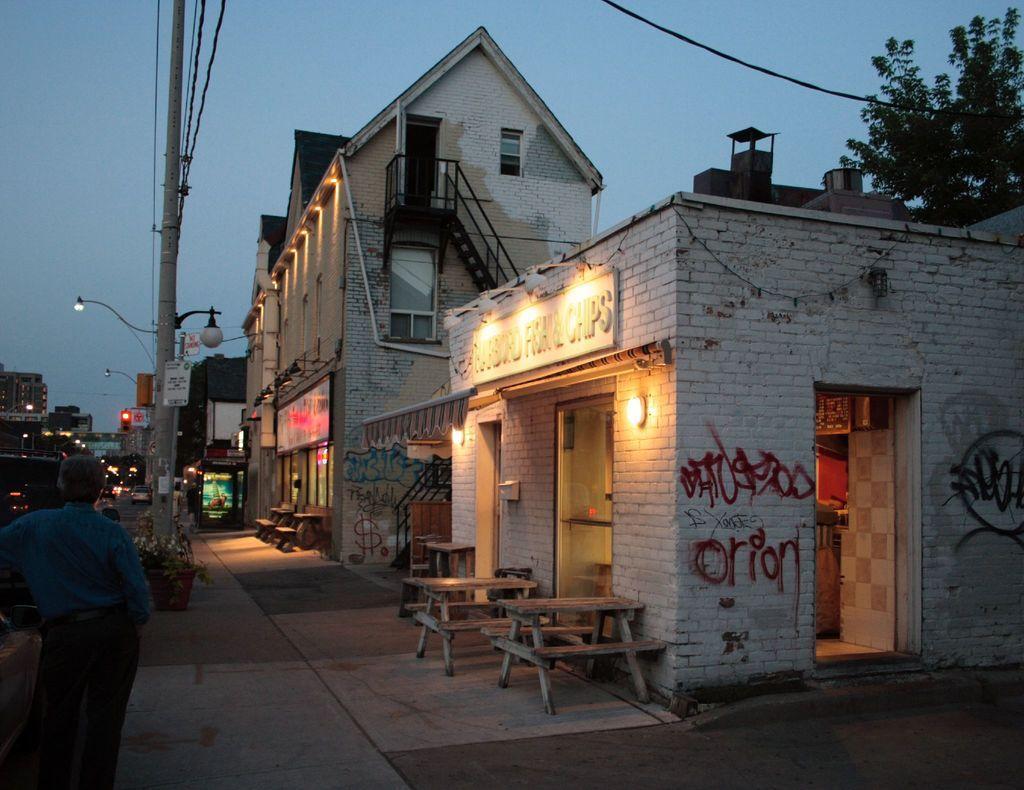Please provide a concise description of this image. This person standing. We can see bench,table,buildings,sky,tree,pole,light. This is plant. 